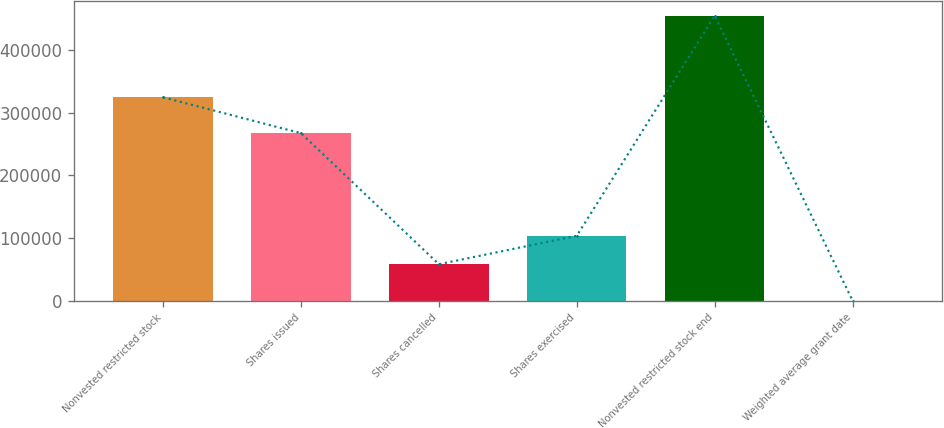Convert chart to OTSL. <chart><loc_0><loc_0><loc_500><loc_500><bar_chart><fcel>Nonvested restricted stock<fcel>Shares issued<fcel>Shares cancelled<fcel>Shares exercised<fcel>Nonvested restricted stock end<fcel>Weighted average grant date<nl><fcel>324289<fcel>267055<fcel>58086<fcel>103531<fcel>454484<fcel>34.77<nl></chart> 